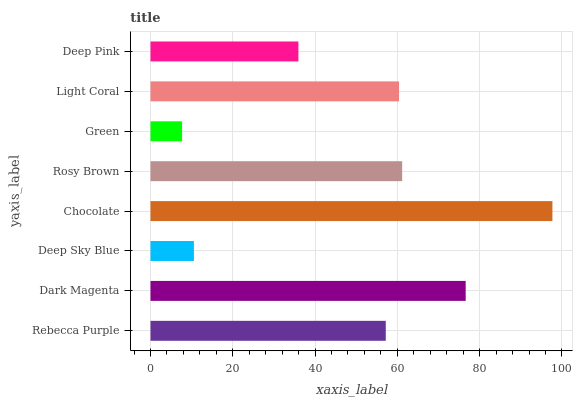Is Green the minimum?
Answer yes or no. Yes. Is Chocolate the maximum?
Answer yes or no. Yes. Is Dark Magenta the minimum?
Answer yes or no. No. Is Dark Magenta the maximum?
Answer yes or no. No. Is Dark Magenta greater than Rebecca Purple?
Answer yes or no. Yes. Is Rebecca Purple less than Dark Magenta?
Answer yes or no. Yes. Is Rebecca Purple greater than Dark Magenta?
Answer yes or no. No. Is Dark Magenta less than Rebecca Purple?
Answer yes or no. No. Is Light Coral the high median?
Answer yes or no. Yes. Is Rebecca Purple the low median?
Answer yes or no. Yes. Is Rebecca Purple the high median?
Answer yes or no. No. Is Green the low median?
Answer yes or no. No. 